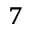Convert formula to latex. <formula><loc_0><loc_0><loc_500><loc_500>^ { 7 }</formula> 